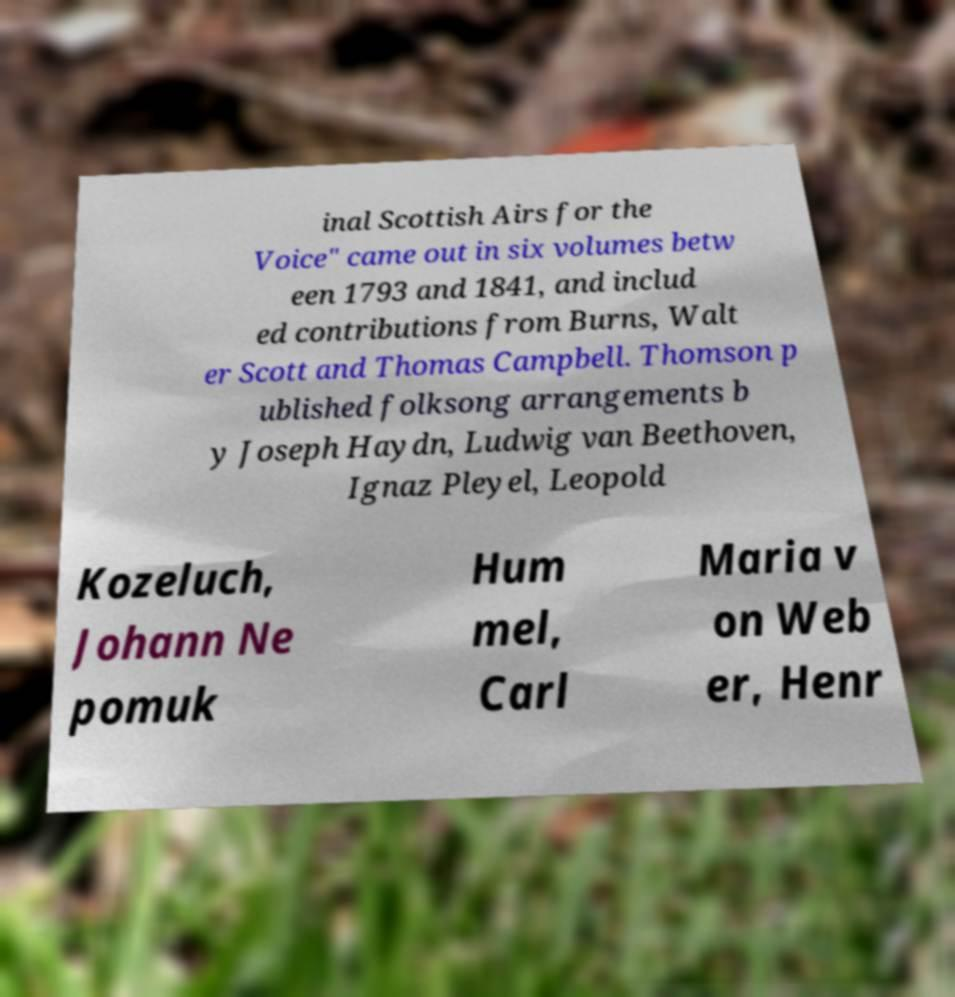Can you read and provide the text displayed in the image?This photo seems to have some interesting text. Can you extract and type it out for me? inal Scottish Airs for the Voice" came out in six volumes betw een 1793 and 1841, and includ ed contributions from Burns, Walt er Scott and Thomas Campbell. Thomson p ublished folksong arrangements b y Joseph Haydn, Ludwig van Beethoven, Ignaz Pleyel, Leopold Kozeluch, Johann Ne pomuk Hum mel, Carl Maria v on Web er, Henr 